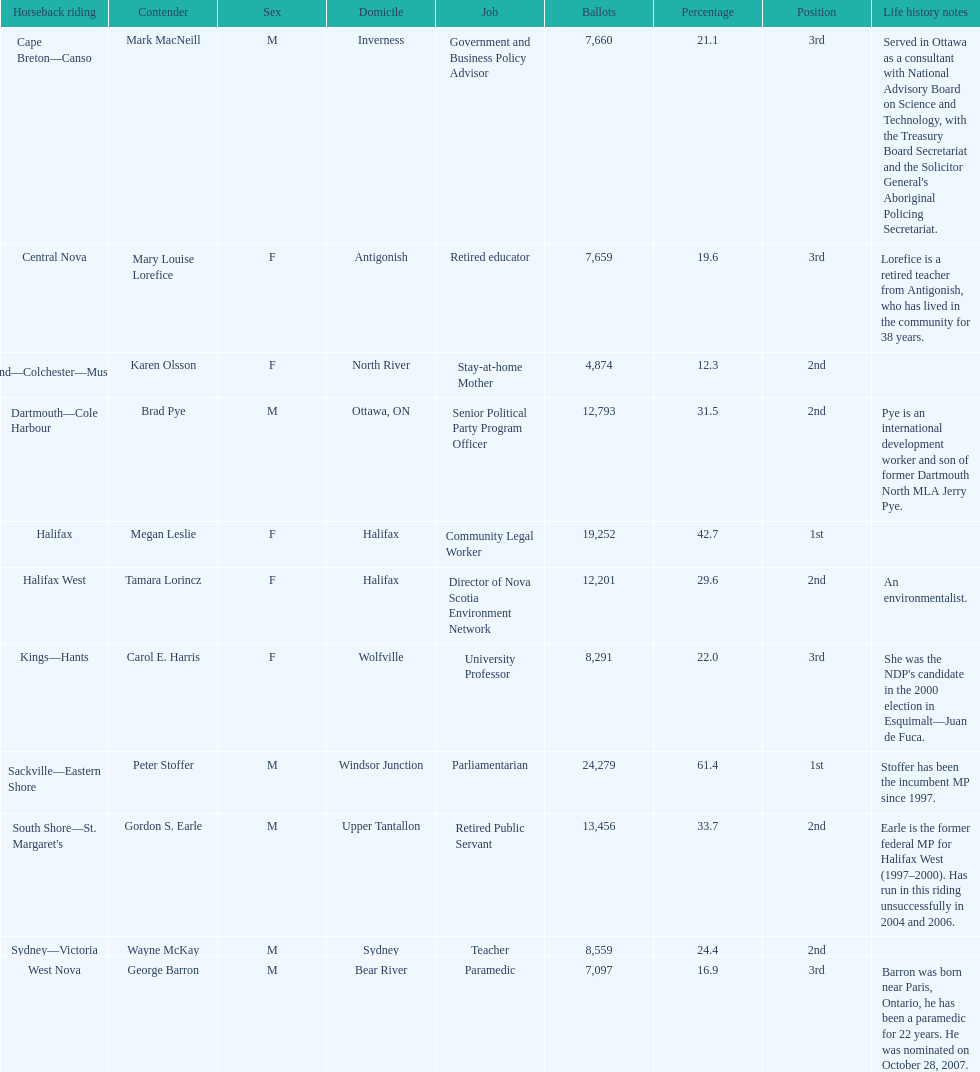Tell me the total number of votes the female candidates got. 52,277. 